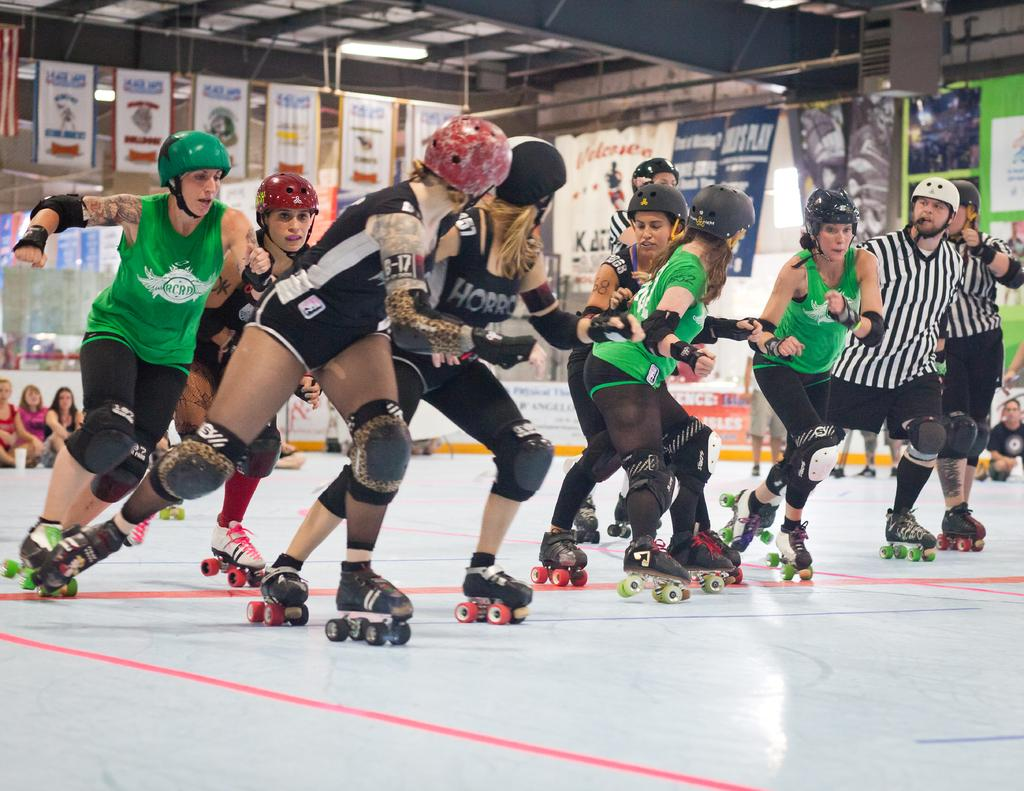What activity are the people in the image engaged in? The people in the image are doing skateboarding. Can you describe the people in the background of the image? There are people sitting on the floor in the background of the image. What else can be seen in the image besides the skateboarders? There are posters visible in the image. How many sheep can be seen in the image? There are no sheep present in the image. What type of stretch is the person doing in the image? There is no person stretching in the image; the people are skateboarding. 